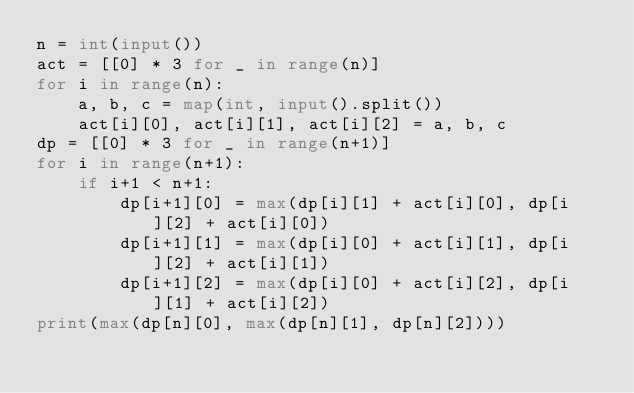Convert code to text. <code><loc_0><loc_0><loc_500><loc_500><_Python_>n = int(input())
act = [[0] * 3 for _ in range(n)]
for i in range(n):
    a, b, c = map(int, input().split())
    act[i][0], act[i][1], act[i][2] = a, b, c
dp = [[0] * 3 for _ in range(n+1)]
for i in range(n+1):
    if i+1 < n+1:
        dp[i+1][0] = max(dp[i][1] + act[i][0], dp[i][2] + act[i][0])
        dp[i+1][1] = max(dp[i][0] + act[i][1], dp[i][2] + act[i][1])
        dp[i+1][2] = max(dp[i][0] + act[i][2], dp[i][1] + act[i][2])
print(max(dp[n][0], max(dp[n][1], dp[n][2])))</code> 